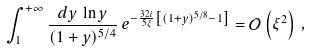Convert formula to latex. <formula><loc_0><loc_0><loc_500><loc_500>\int _ { 1 } ^ { + \infty } \frac { d y \, \ln y } { ( 1 + y ) ^ { 5 / 4 } } \, e ^ { - \frac { 3 2 i } { 5 \xi } \left [ ( 1 + y ) ^ { 5 / 8 } - 1 \right ] } = \mathcal { O } \left ( \xi ^ { 2 } \right ) \, ,</formula> 